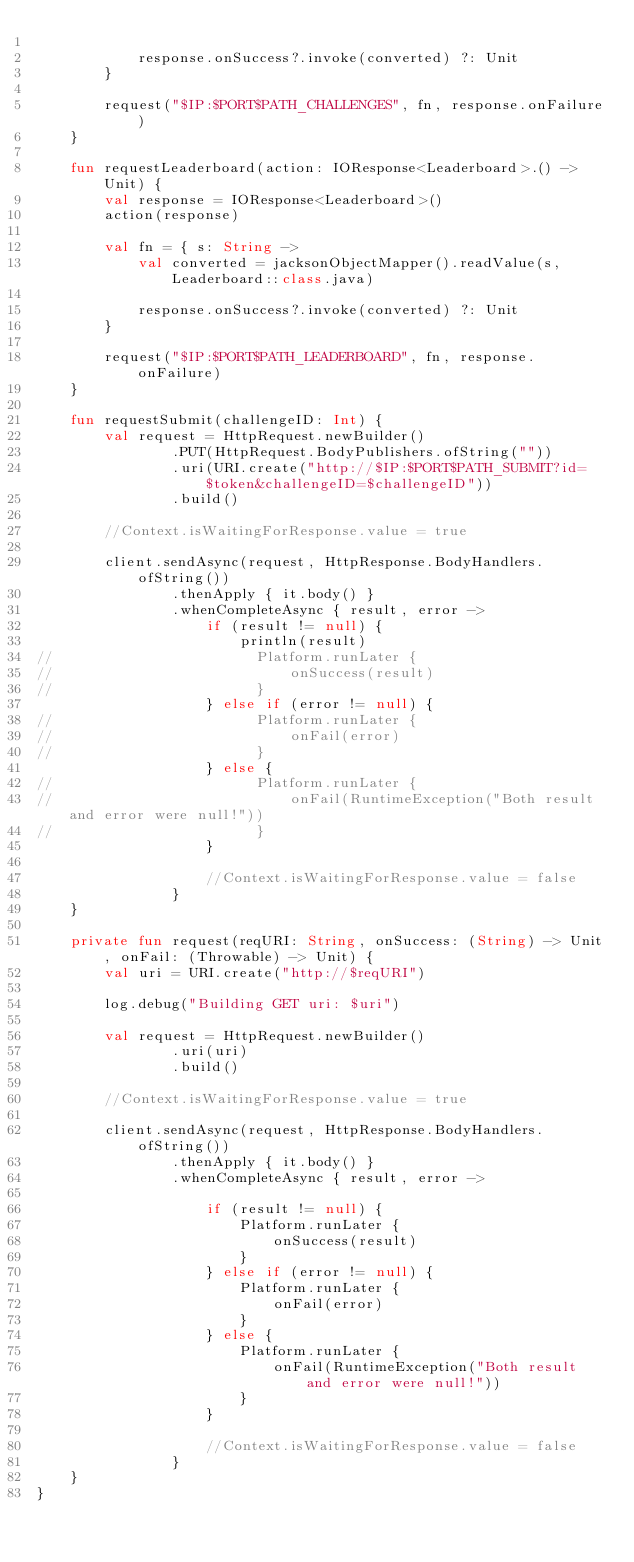Convert code to text. <code><loc_0><loc_0><loc_500><loc_500><_Kotlin_>
            response.onSuccess?.invoke(converted) ?: Unit
        }

        request("$IP:$PORT$PATH_CHALLENGES", fn, response.onFailure)
    }

    fun requestLeaderboard(action: IOResponse<Leaderboard>.() -> Unit) {
        val response = IOResponse<Leaderboard>()
        action(response)

        val fn = { s: String ->
            val converted = jacksonObjectMapper().readValue(s, Leaderboard::class.java)

            response.onSuccess?.invoke(converted) ?: Unit
        }

        request("$IP:$PORT$PATH_LEADERBOARD", fn, response.onFailure)
    }

    fun requestSubmit(challengeID: Int) {
        val request = HttpRequest.newBuilder()
                .PUT(HttpRequest.BodyPublishers.ofString(""))
                .uri(URI.create("http://$IP:$PORT$PATH_SUBMIT?id=$token&challengeID=$challengeID"))
                .build()

        //Context.isWaitingForResponse.value = true

        client.sendAsync(request, HttpResponse.BodyHandlers.ofString())
                .thenApply { it.body() }
                .whenCompleteAsync { result, error ->
                    if (result != null) {
                        println(result)
//                        Platform.runLater {
//                            onSuccess(result)
//                        }
                    } else if (error != null) {
//                        Platform.runLater {
//                            onFail(error)
//                        }
                    } else {
//                        Platform.runLater {
//                            onFail(RuntimeException("Both result and error were null!"))
//                        }
                    }

                    //Context.isWaitingForResponse.value = false
                }
    }

    private fun request(reqURI: String, onSuccess: (String) -> Unit, onFail: (Throwable) -> Unit) {
        val uri = URI.create("http://$reqURI")

        log.debug("Building GET uri: $uri")

        val request = HttpRequest.newBuilder()
                .uri(uri)
                .build()

        //Context.isWaitingForResponse.value = true

        client.sendAsync(request, HttpResponse.BodyHandlers.ofString())
                .thenApply { it.body() }
                .whenCompleteAsync { result, error ->

                    if (result != null) {
                        Platform.runLater {
                            onSuccess(result)
                        }
                    } else if (error != null) {
                        Platform.runLater {
                            onFail(error)
                        }
                    } else {
                        Platform.runLater {
                            onFail(RuntimeException("Both result and error were null!"))
                        }
                    }

                    //Context.isWaitingForResponse.value = false
                }
    }
}



</code> 